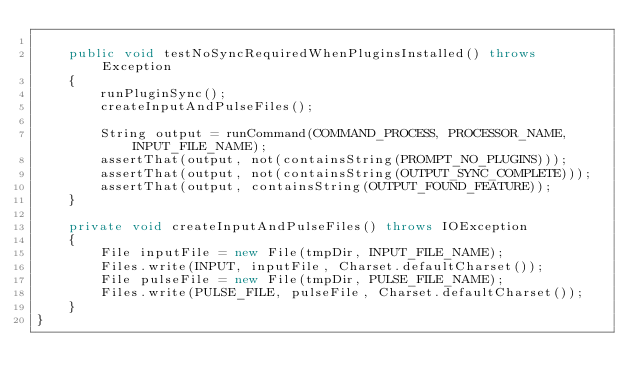Convert code to text. <code><loc_0><loc_0><loc_500><loc_500><_Java_>
    public void testNoSyncRequiredWhenPluginsInstalled() throws Exception
    {
        runPluginSync();
        createInputAndPulseFiles();
        
        String output = runCommand(COMMAND_PROCESS, PROCESSOR_NAME, INPUT_FILE_NAME);
        assertThat(output, not(containsString(PROMPT_NO_PLUGINS)));
        assertThat(output, not(containsString(OUTPUT_SYNC_COMPLETE)));
        assertThat(output, containsString(OUTPUT_FOUND_FEATURE));
    }

    private void createInputAndPulseFiles() throws IOException
    {
        File inputFile = new File(tmpDir, INPUT_FILE_NAME);
        Files.write(INPUT, inputFile, Charset.defaultCharset());
        File pulseFile = new File(tmpDir, PULSE_FILE_NAME);
        Files.write(PULSE_FILE, pulseFile, Charset.defaultCharset());
    }
}
</code> 